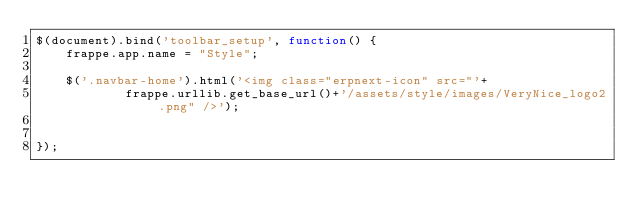<code> <loc_0><loc_0><loc_500><loc_500><_JavaScript_>$(document).bind('toolbar_setup', function() {
	frappe.app.name = "Style";

	$('.navbar-home').html('<img class="erpnext-icon" src="'+
			frappe.urllib.get_base_url()+'/assets/style/images/VeryNice_logo2.png" />');


});


</code> 